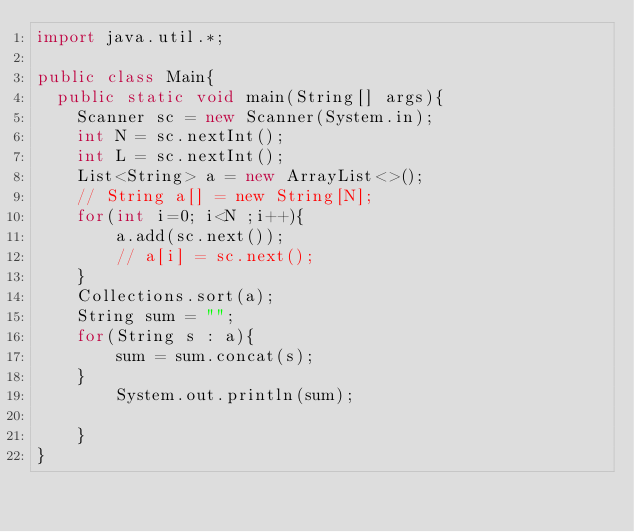<code> <loc_0><loc_0><loc_500><loc_500><_Java_>import java.util.*;

public class Main{
  public static void main(String[] args){
    Scanner sc = new Scanner(System.in);
    int N = sc.nextInt();
    int L = sc.nextInt();
    List<String> a = new ArrayList<>();
    // String a[] = new String[N];
    for(int i=0; i<N ;i++){
        a.add(sc.next());
        // a[i] = sc.next();
    }
    Collections.sort(a);
    String sum = "";
    for(String s : a){
        sum = sum.concat(s);
    }
        System.out.println(sum); 

    }    
}
</code> 